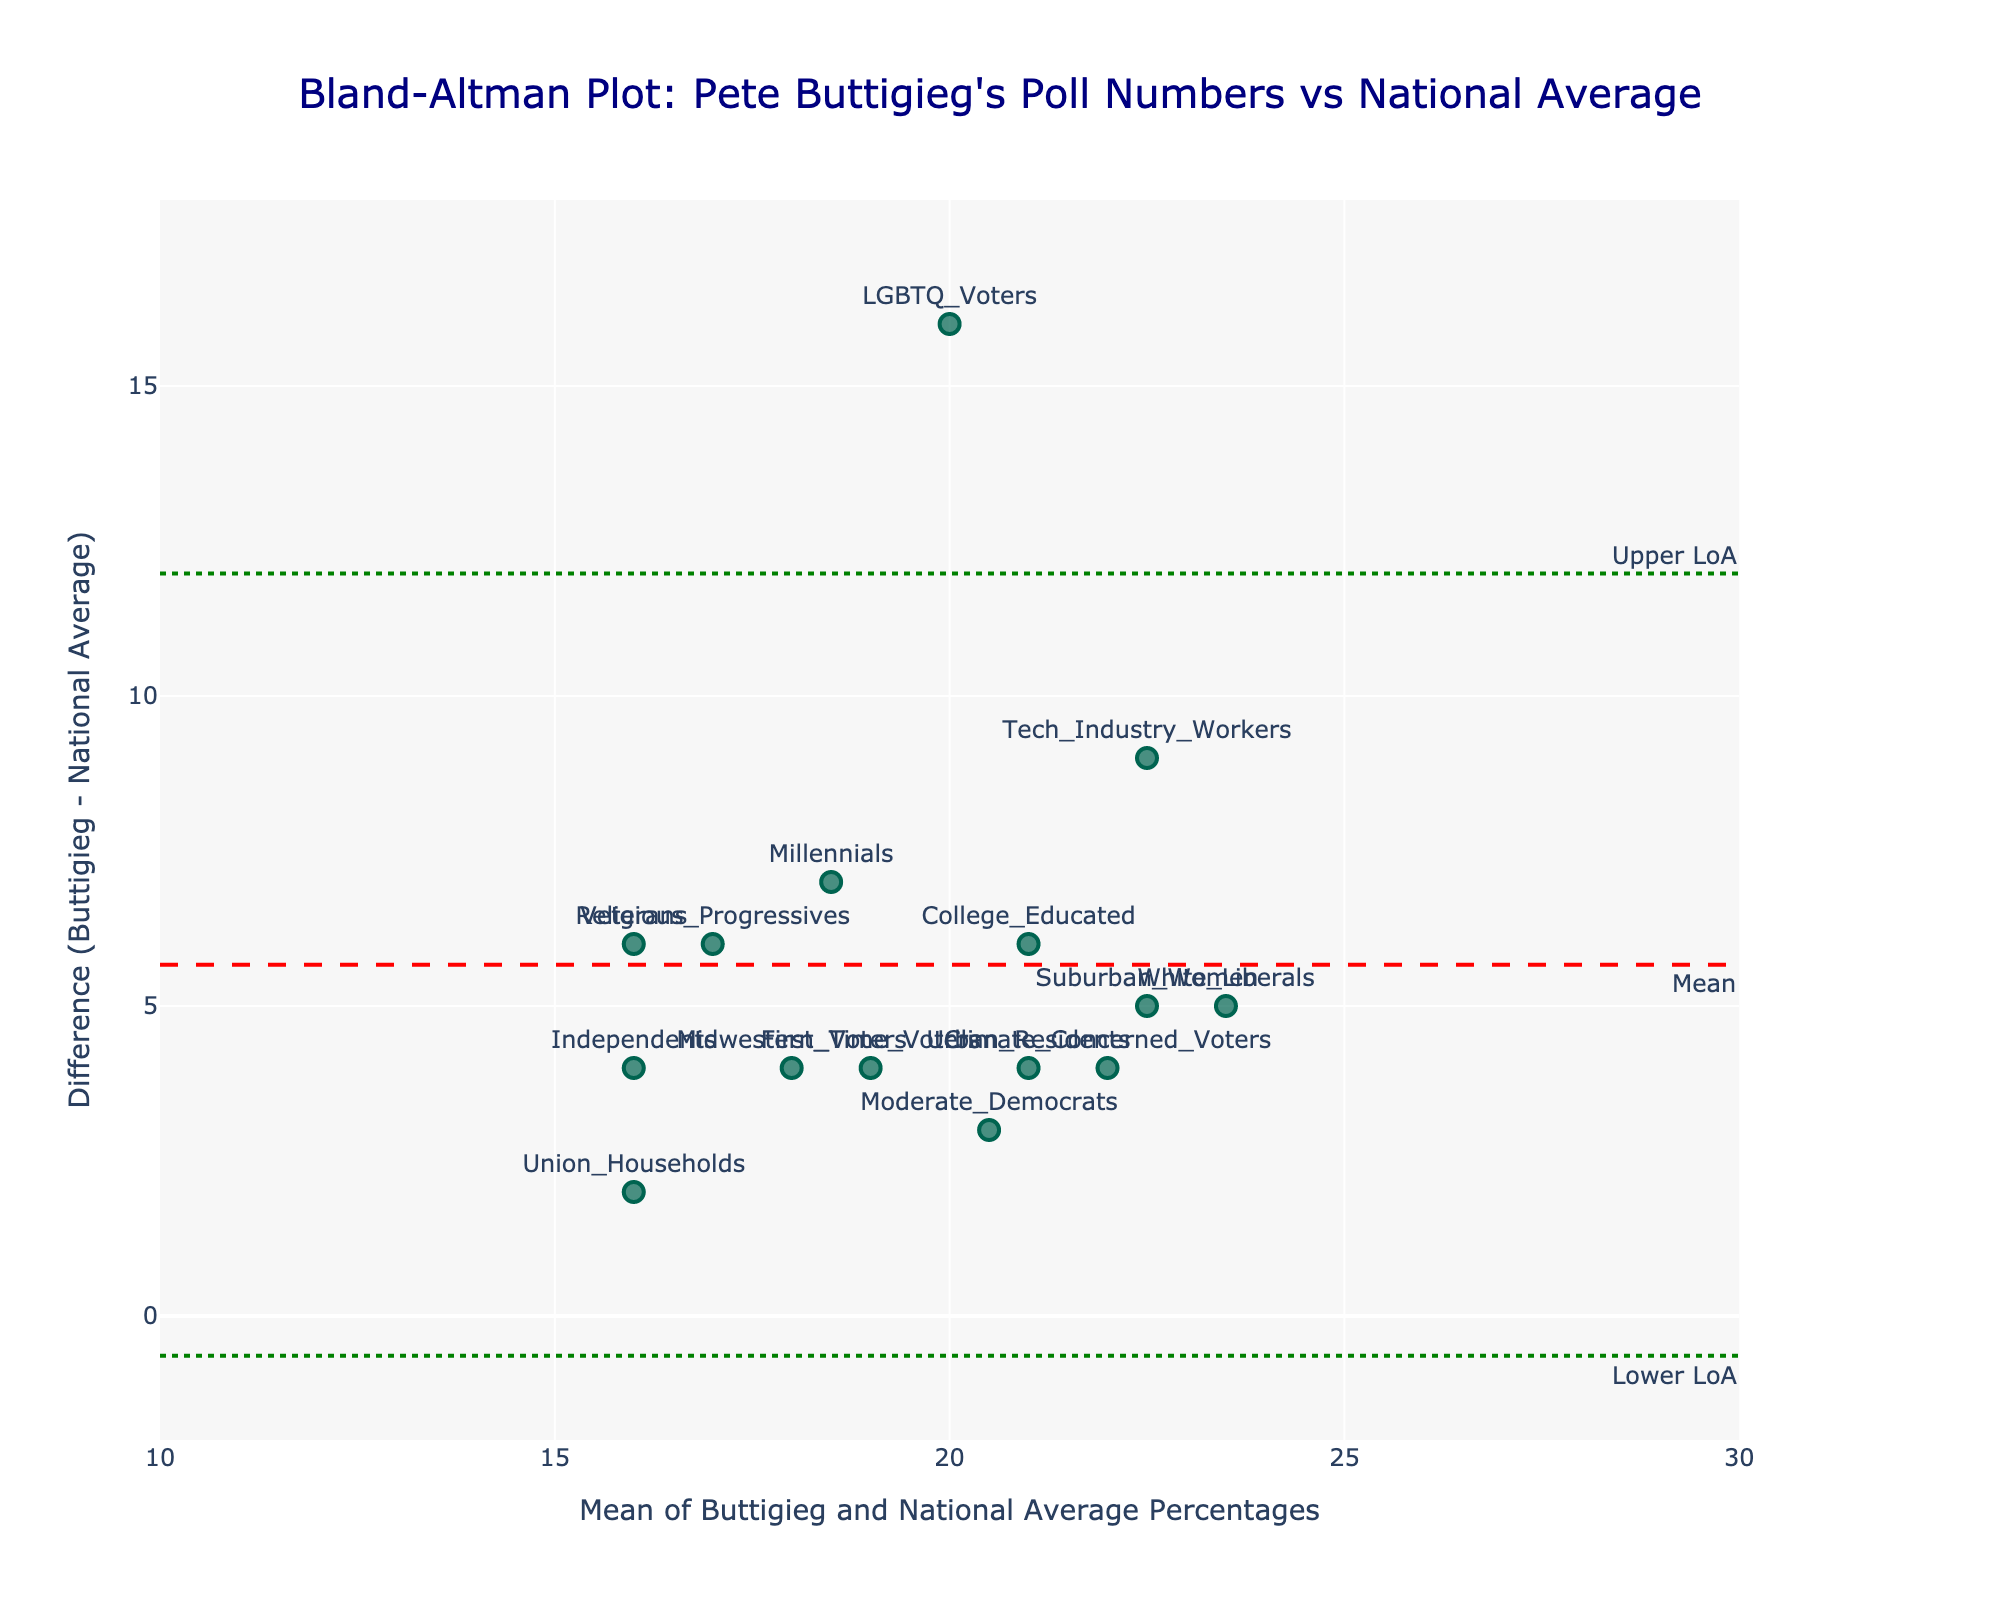What's the title of the plot? The title of the plot is usually placed at the top center of the figure. Here, the title reads "Bland-Altman Plot: Pete Buttigieg's Poll Numbers vs National Average"
Answer: Bland-Altman Plot: Pete Buttigieg's Poll Numbers vs National Average How many data points are displayed in the plot? The Bland-Altman plot shows each demographic group as a distinct marker. Counting these markers gives the total number of data points.
Answer: 15 Which demographic group has the highest difference between Buttigieg's poll percentage and the national average? To determine this, find the point with the highest position on the y-axis (difference). In this plot, LGBTQ Voters show the highest difference.
Answer: LGBTQ Voters What is the mean difference between Pete Buttigieg's poll percentages and the national average? The mean difference line is indicated in red and labeled "Mean." This line positions the central tendency of differences.
Answer: 5.87 What are the upper and lower limits of agreement in the plot? The upper and lower limits of agreement are the green dotted lines labeled "Upper LoA" and "Lower LoA." The values can be found in their corresponding annotations.
Answer: Upper LoA: 12.81, Lower LoA: -1.07 Which demographic group has the smallest difference between Buttigieg's poll percentage and the national average? Identify the point closest to the x-axis with the smallest distance from zero. Union Households has the smallest difference.
Answer: Union Households For the demographic “College Educated,” what is the mean of Buttigieg and the national average percentages? For "College Educated," calculate the mean of Buttigieg's percentage (24) and the national average (18). (24 + 18) / 2 = 21
Answer: 21 What is the standard deviation of the differences observed in the plot? The standard deviation is derived from the distribution of differences. It is not clearly marked but can be inferred from the agreement limits formula: std = (Upper LoA - Mean Difference) / 1.96. Here, (12.81 - 5.87) / 1.96 =~ 3.54
Answer: 3.54 Is Buttigieg more popular among demographics with higher mean values or lower mean values compared to the national average? By evaluating the plot, observe whether points above the mean difference line (indicating positive differences) are aligned with higher x-axis values (mean percentages). As most differences above the mean differ from higher x-axis values, he is more popular in those demographics.
Answer: Higher mean values 